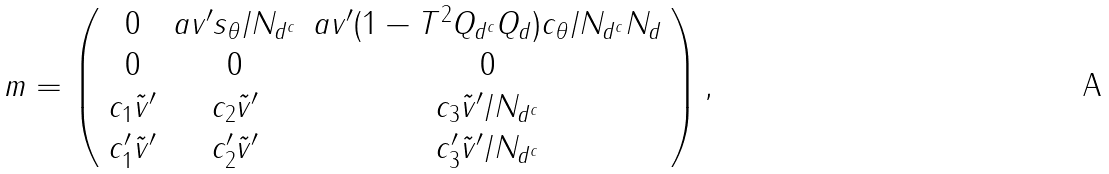<formula> <loc_0><loc_0><loc_500><loc_500>m = \left ( \begin{array} { c c c } 0 & a v ^ { \prime } s _ { \theta } / N _ { d ^ { c } } & a v ^ { \prime } ( 1 - T ^ { 2 } Q _ { d ^ { c } } Q _ { d } ) c _ { \theta } / N _ { d ^ { c } } N _ { d } \\ 0 & 0 & 0 \\ c _ { 1 } \tilde { v } ^ { \prime } & c _ { 2 } \tilde { v } ^ { \prime } & c _ { 3 } \tilde { v } ^ { \prime } / N _ { d ^ { c } } \\ c _ { 1 } ^ { \prime } \tilde { v } ^ { \prime } & c _ { 2 } ^ { \prime } \tilde { v } ^ { \prime } & c _ { 3 } ^ { \prime } \tilde { v } ^ { \prime } / N _ { d ^ { c } } \end{array} \right ) ,</formula> 